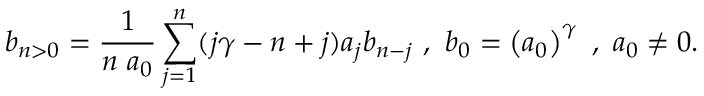<formula> <loc_0><loc_0><loc_500><loc_500>b _ { n > 0 } = \frac { 1 } { n a _ { 0 } } \sum _ { j = 1 } ^ { n } ( j \gamma - n + j ) a _ { j } b _ { n - j } , b _ { 0 } = \left ( a _ { 0 } \right ) ^ { \gamma } , a _ { 0 } \neq 0 .</formula> 